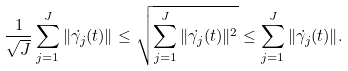Convert formula to latex. <formula><loc_0><loc_0><loc_500><loc_500>\frac { 1 } { \sqrt { J } } \sum _ { j = 1 } ^ { J } \| \dot { \gamma _ { j } } ( t ) \| \leq \sqrt { \sum _ { j = 1 } ^ { J } \| \dot { \gamma _ { j } } ( t ) \| ^ { 2 } } \leq \sum _ { j = 1 } ^ { J } \| \dot { \gamma _ { j } } ( t ) \| .</formula> 